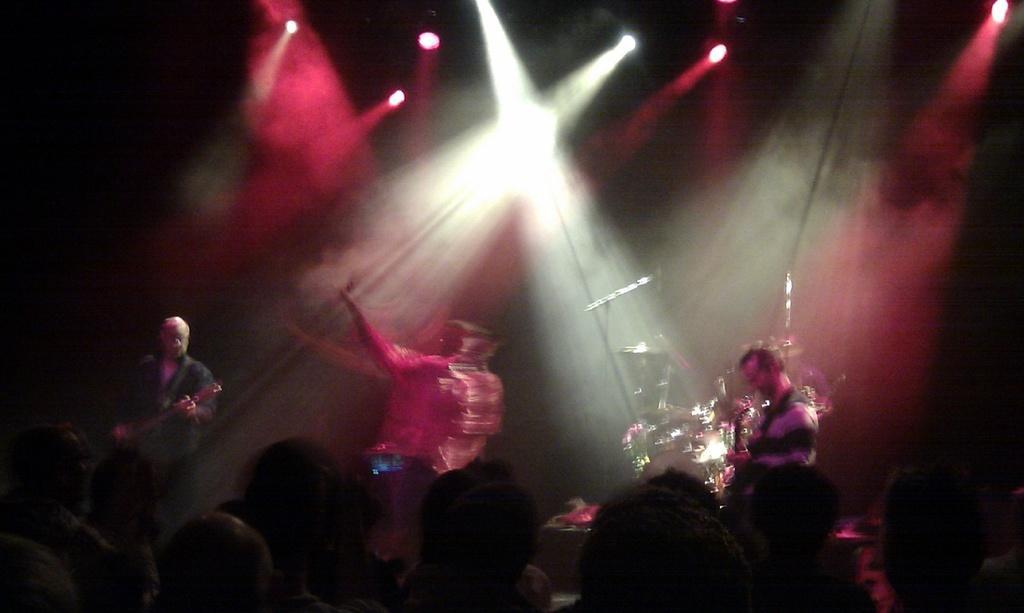Could you give a brief overview of what you see in this image? In this image I can see there are persons playing a musical instrument. And at the top there is a light by reflection. And at the side, it looks like a dark. And at the back there are musical instruments. 